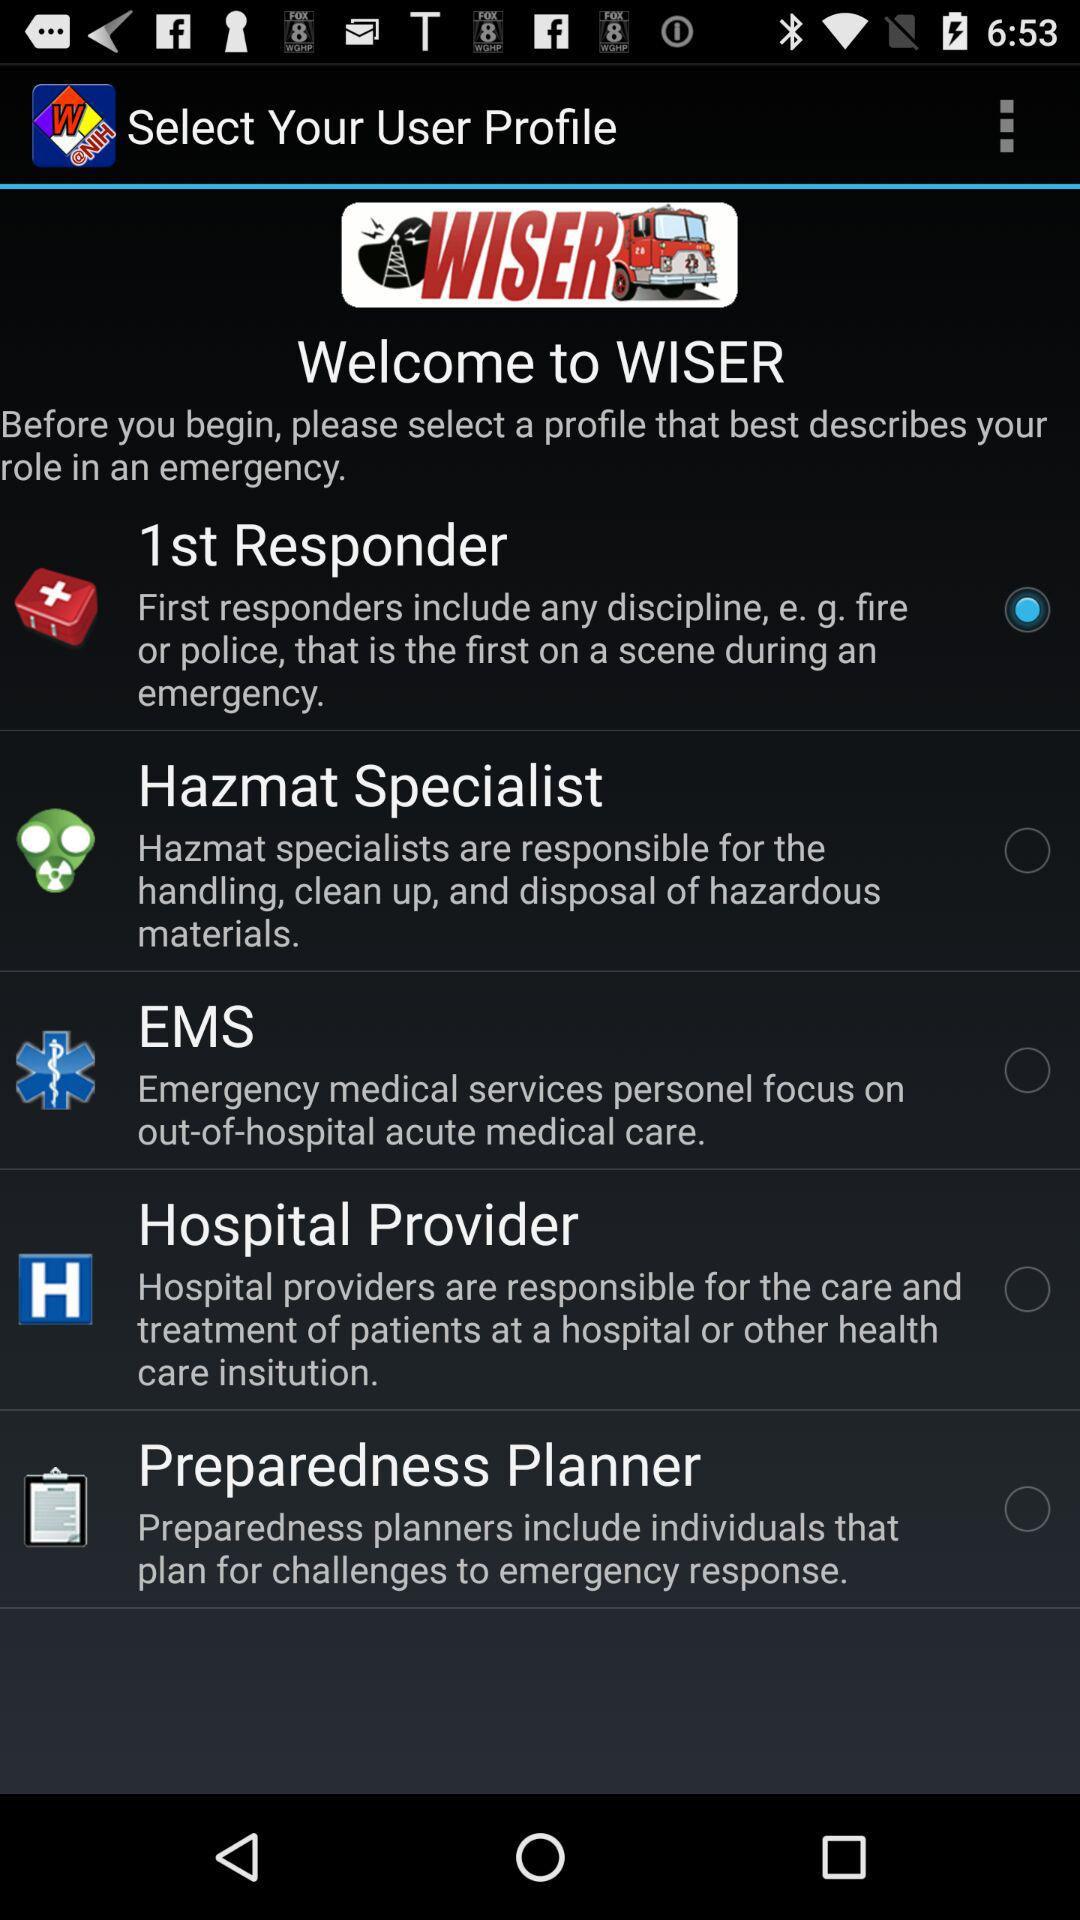What is the name of the application? The name of the application is "WISER". 